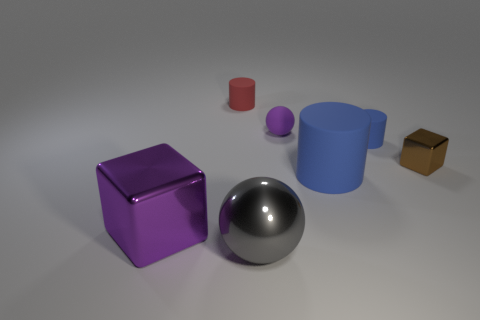Add 1 yellow metal spheres. How many objects exist? 8 Subtract all cubes. How many objects are left? 5 Subtract 1 brown cubes. How many objects are left? 6 Subtract all tiny cyan shiny cubes. Subtract all big blue cylinders. How many objects are left? 6 Add 2 brown things. How many brown things are left? 3 Add 7 large yellow rubber cylinders. How many large yellow rubber cylinders exist? 7 